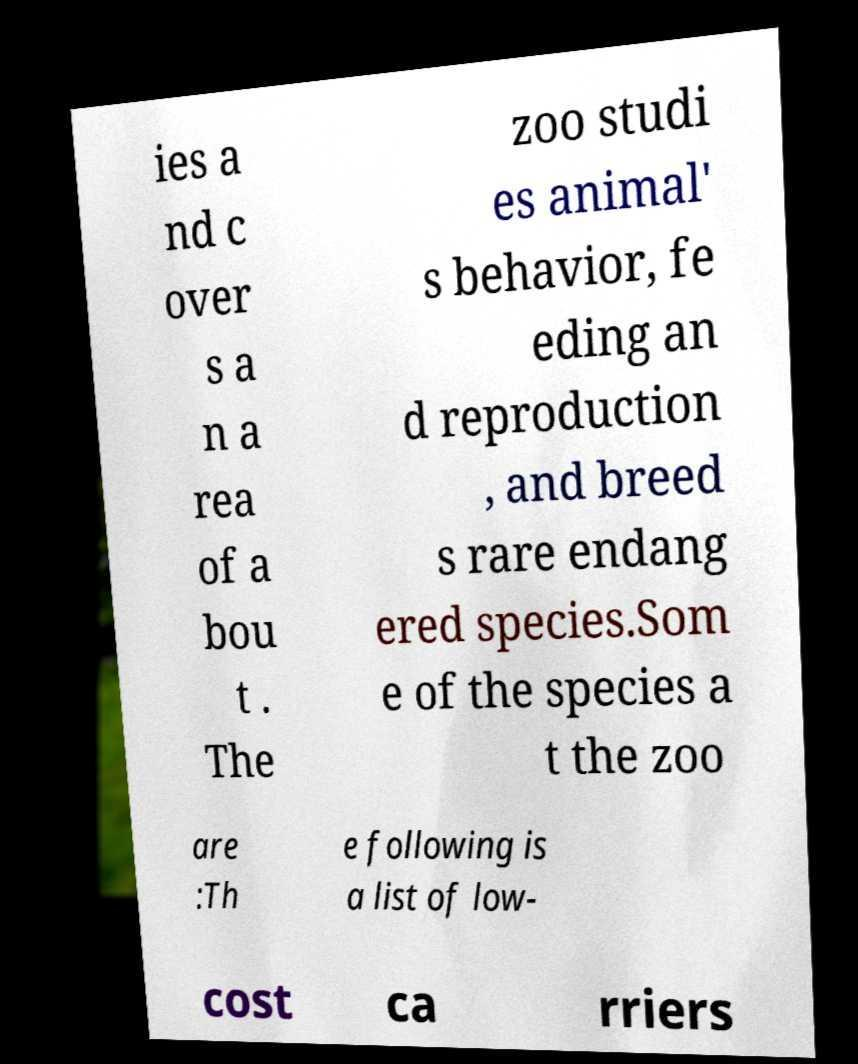For documentation purposes, I need the text within this image transcribed. Could you provide that? ies a nd c over s a n a rea of a bou t . The zoo studi es animal' s behavior, fe eding an d reproduction , and breed s rare endang ered species.Som e of the species a t the zoo are :Th e following is a list of low- cost ca rriers 